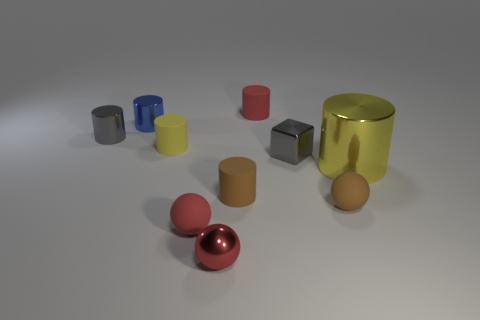Are the tiny ball on the right side of the small red metal thing and the blue object made of the same material? Based on the visual characteristics observed in the image, the tiny ball on the right side of the small red object appears to have a reflective metallic finish, similar to that of the red object nearby. The blue object, on the other hand, exhibits a more opaque and less reflective surface, indicating that it is unlikely made of the same material as the metallic ball. 